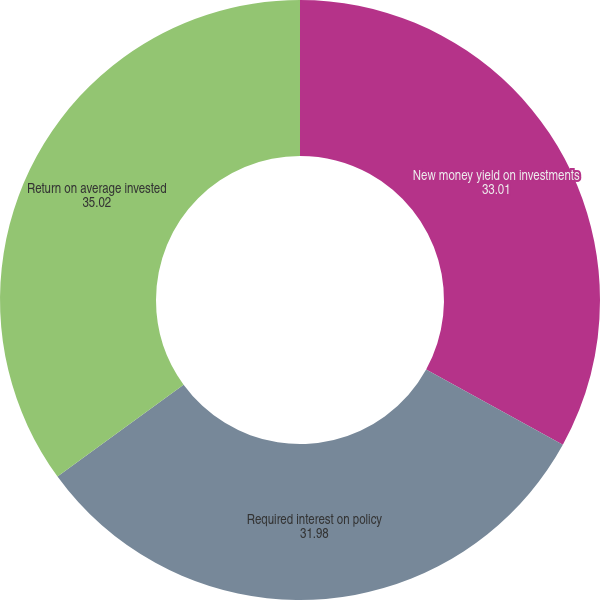Convert chart to OTSL. <chart><loc_0><loc_0><loc_500><loc_500><pie_chart><fcel>New money yield on investments<fcel>Required interest on policy<fcel>Return on average invested<nl><fcel>33.01%<fcel>31.98%<fcel>35.02%<nl></chart> 